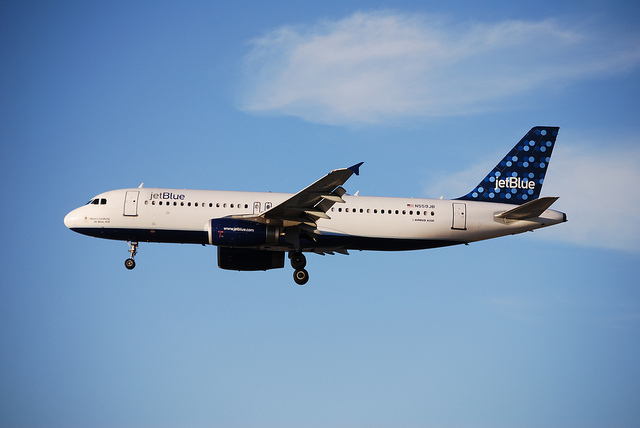Extract all visible text content from this image. jetBlue jetBlue 